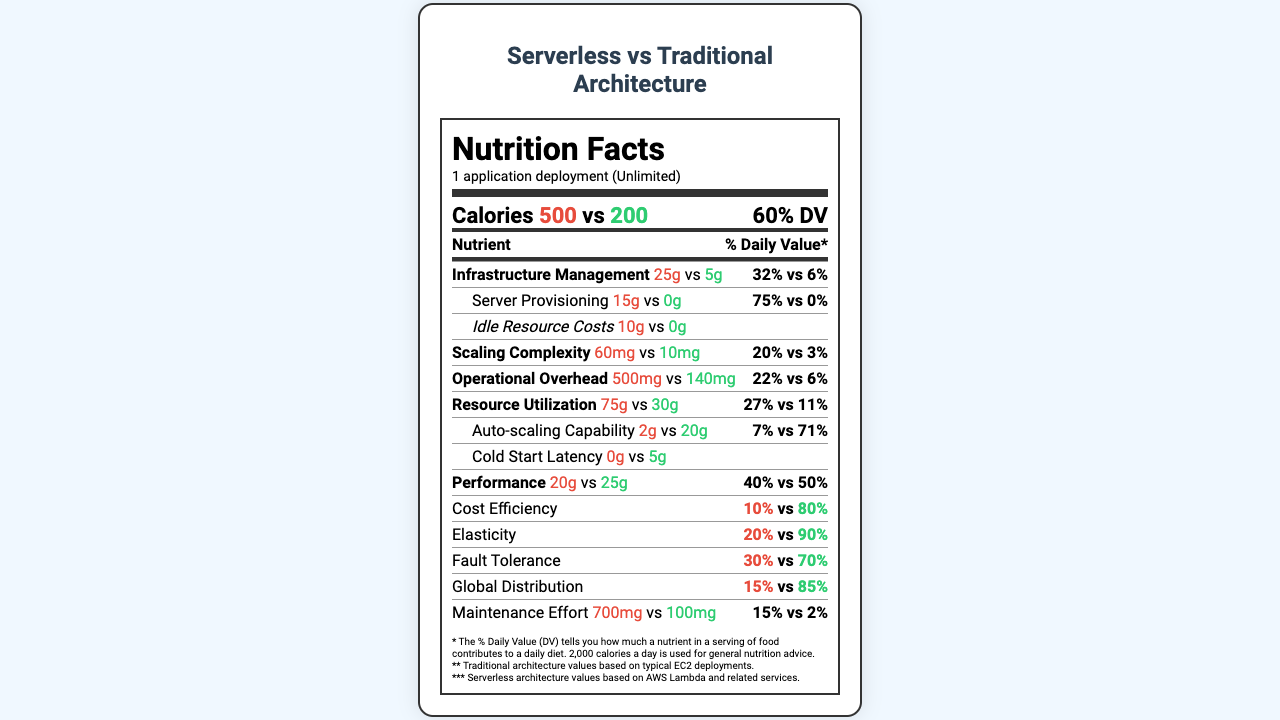what is the serving size? The serving size is clearly mentioned at the top of the document as "1 application deployment".
Answer: 1 application deployment what are the calories for traditional and serverless architectures? The calorie count for both architectures is provided at the top section of the nutrient label.
Answer: Traditional: 500, Serverless: 200 how much is the Infrastructure Management fat content for serverless architecture? The Infrastructure Management fat content for serverless architecture is mentioned as 5g.
Answer: 5g which type of architecture has higher cholesterol? Traditional architecture has 60mg of cholesterol, whereas serverless has only 10mg.
Answer: Traditional what is the total carbohydrate daily value percentage for serverless architecture? The daily value percentage for total carbohydrate in the serverless architecture is 11%.
Answer: 11% what is the daily value percentage difference for Auto-scaling Capability between traditional and serverless architectures? Auto-scaling Capability has a daily value of 7% for traditional and 71% for serverless architecture, making it 64% higher for serverless.
Answer: 64% more for serverless architecture how does the Maintenance Effort compare between traditional and serverless architecture? (A) Traditional: 700mg vs Serverless: 100mg (B) Traditional: 500mg vs Serverless: 200mg (C) Traditional: 600mg vs Serverless: 300mg The Maintenance Effort for traditional is 700mg and for serverless is 100mg.
Answer: A which architecture has zero Idle Resource Costs? (i) Traditional (ii) Serverless (iii) Both (iv) Neither Serverless architecture has 0g of Idle Resource Costs, while traditional has 10g.
Answer: ii is cold start latency higher in serverless architecture? The serverless architecture has 5g of cold start latency compared to 0g in traditional architecture.
Answer: Yes summarize the main differences between traditional and serverless architectures as presented in the document. The document discusses various metrics, showing that serverless architecture results in greatly reduced operational complexities and costs while enhancing elasticity and fault tolerance compared to traditional architecture.
Answer: Serverless architecture is more cost-efficient, easier to scale, has lower operational overheads, and fewer infrastructure management requirements compared to traditional architecture. Traditional architecture has higher idle resource costs and higher scaling complexity. what is the precise cost efficiency increase from traditional to serverless architecture? The document mentions percentages for cost efficiency (10% for traditional and 80% for serverless), but it does not provide exact costs or a precise calculation method.
Answer: Cannot be determined 